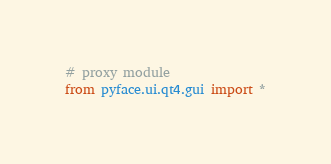Convert code to text. <code><loc_0><loc_0><loc_500><loc_500><_Python_># proxy module
from pyface.ui.qt4.gui import *
</code> 